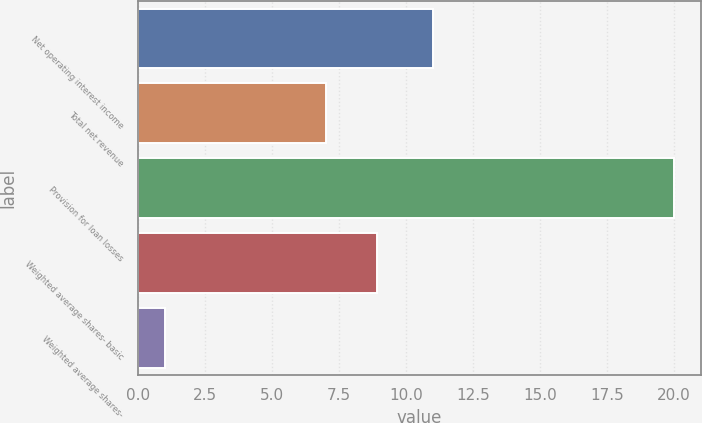Convert chart to OTSL. <chart><loc_0><loc_0><loc_500><loc_500><bar_chart><fcel>Net operating interest income<fcel>Total net revenue<fcel>Provision for loan losses<fcel>Weighted average shares- basic<fcel>Weighted average shares-<nl><fcel>11<fcel>7<fcel>20<fcel>8.9<fcel>1<nl></chart> 